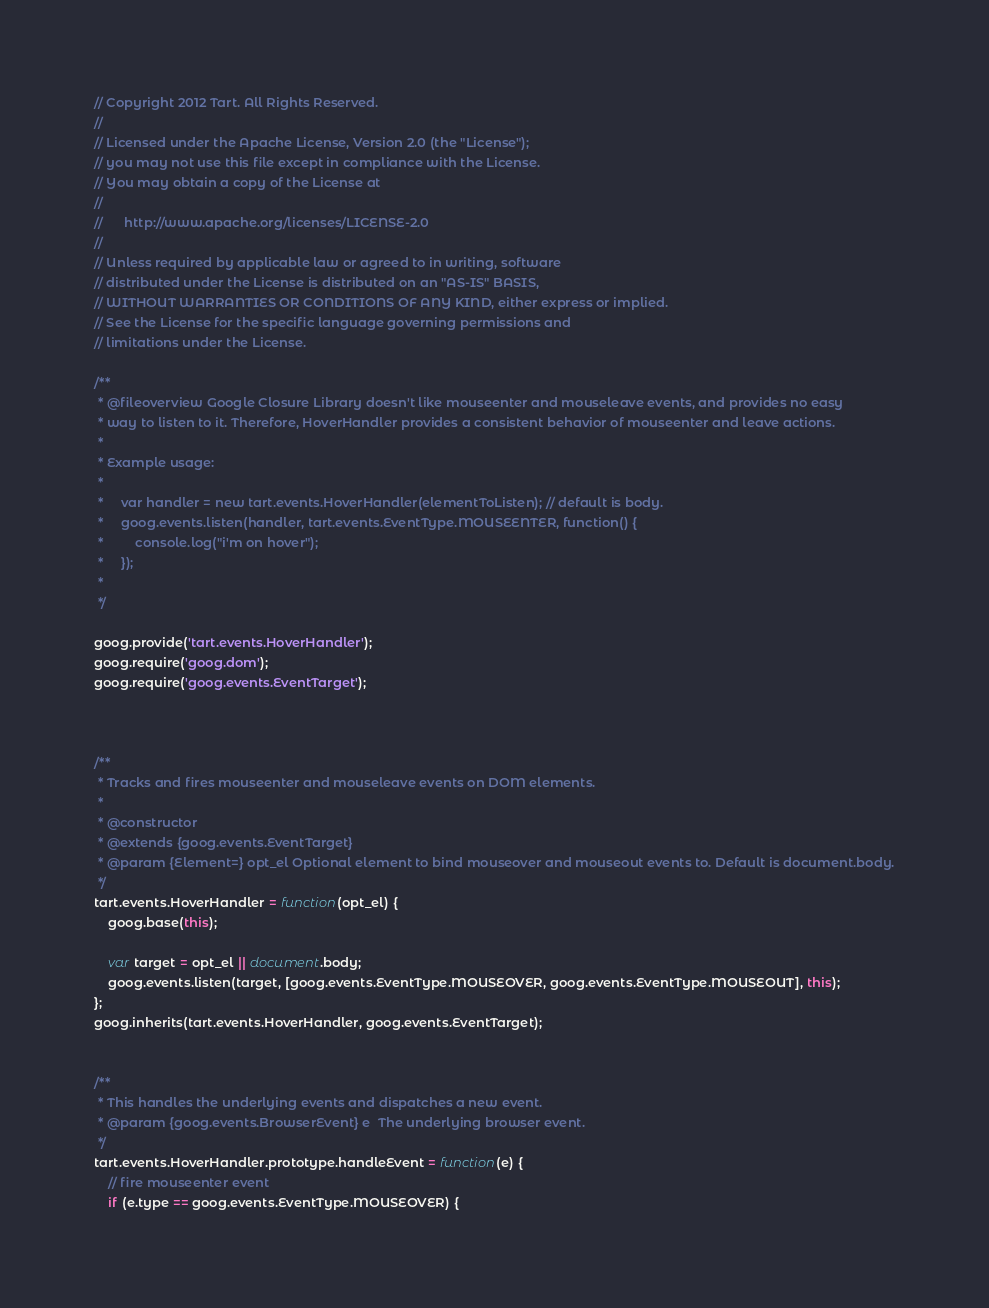<code> <loc_0><loc_0><loc_500><loc_500><_JavaScript_>// Copyright 2012 Tart. All Rights Reserved.
//
// Licensed under the Apache License, Version 2.0 (the "License");
// you may not use this file except in compliance with the License.
// You may obtain a copy of the License at
//
//      http://www.apache.org/licenses/LICENSE-2.0
//
// Unless required by applicable law or agreed to in writing, software
// distributed under the License is distributed on an "AS-IS" BASIS,
// WITHOUT WARRANTIES OR CONDITIONS OF ANY KIND, either express or implied.
// See the License for the specific language governing permissions and
// limitations under the License.

/**
 * @fileoverview Google Closure Library doesn't like mouseenter and mouseleave events, and provides no easy
 * way to listen to it. Therefore, HoverHandler provides a consistent behavior of mouseenter and leave actions.
 *
 * Example usage:
 *
 *     var handler = new tart.events.HoverHandler(elementToListen); // default is body.
 *     goog.events.listen(handler, tart.events.EventType.MOUSEENTER, function() {
 *         console.log("i'm on hover");
 *     });
 *
 */

goog.provide('tart.events.HoverHandler');
goog.require('goog.dom');
goog.require('goog.events.EventTarget');



/**
 * Tracks and fires mouseenter and mouseleave events on DOM elements.
 *
 * @constructor
 * @extends {goog.events.EventTarget}
 * @param {Element=} opt_el Optional element to bind mouseover and mouseout events to. Default is document.body.
 */
tart.events.HoverHandler = function(opt_el) {
    goog.base(this);

    var target = opt_el || document.body;
    goog.events.listen(target, [goog.events.EventType.MOUSEOVER, goog.events.EventType.MOUSEOUT], this);
};
goog.inherits(tart.events.HoverHandler, goog.events.EventTarget);


/**
 * This handles the underlying events and dispatches a new event.
 * @param {goog.events.BrowserEvent} e  The underlying browser event.
 */
tart.events.HoverHandler.prototype.handleEvent = function(e) {
    // fire mouseenter event
    if (e.type == goog.events.EventType.MOUSEOVER) {</code> 